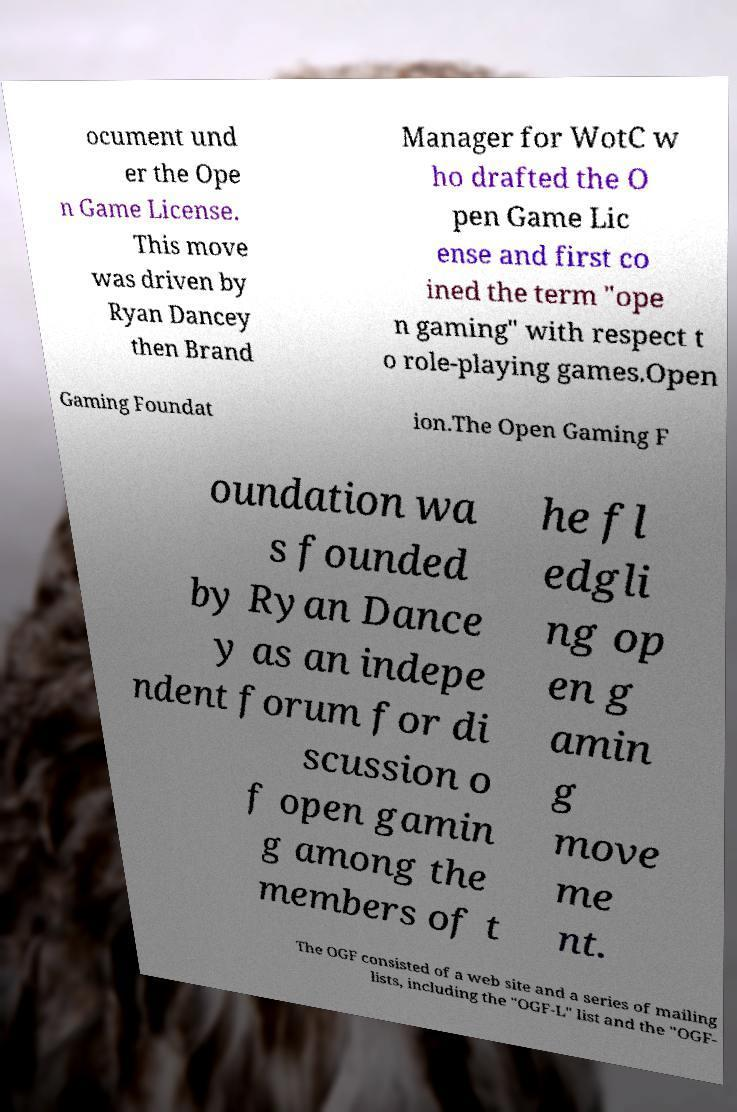Could you assist in decoding the text presented in this image and type it out clearly? ocument und er the Ope n Game License. This move was driven by Ryan Dancey then Brand Manager for WotC w ho drafted the O pen Game Lic ense and first co ined the term "ope n gaming" with respect t o role-playing games.Open Gaming Foundat ion.The Open Gaming F oundation wa s founded by Ryan Dance y as an indepe ndent forum for di scussion o f open gamin g among the members of t he fl edgli ng op en g amin g move me nt. The OGF consisted of a web site and a series of mailing lists, including the "OGF-L" list and the "OGF- 